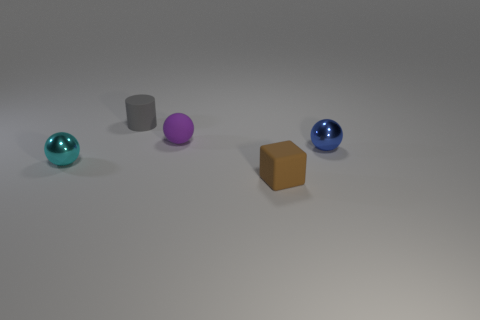What size is the sphere that is to the left of the tiny matte cylinder?
Offer a very short reply. Small. How many blue objects have the same size as the gray object?
Your answer should be very brief. 1. There is a cyan ball; is its size the same as the shiny sphere that is to the right of the brown matte thing?
Ensure brevity in your answer.  Yes. What number of objects are big red metallic cubes or matte cylinders?
Your answer should be very brief. 1. What number of balls have the same color as the matte cylinder?
Make the answer very short. 0. The brown object that is the same size as the blue ball is what shape?
Make the answer very short. Cube. Is there a matte thing that has the same shape as the cyan metallic thing?
Keep it short and to the point. Yes. How many other small spheres have the same material as the blue ball?
Offer a very short reply. 1. Is the object that is behind the small purple ball made of the same material as the tiny brown block?
Offer a terse response. Yes. Is the number of small brown matte cubes that are left of the small gray matte object greater than the number of small metal spheres that are in front of the tiny cyan metal thing?
Your answer should be very brief. No. 